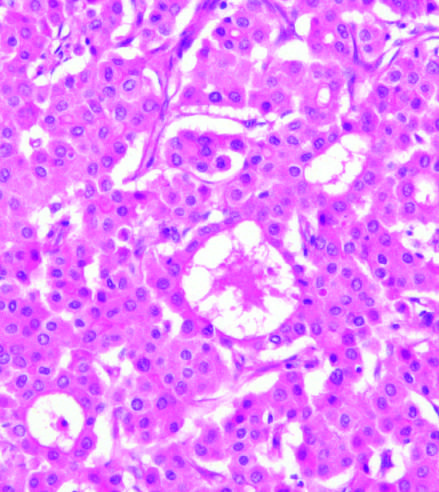did malignant hepatocytes grow in distorted versions of normal architecture : large pseudoacinar spaces, essentially malformed, dilated bile canaliculi?
Answer the question using a single word or phrase. Yes 